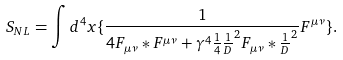<formula> <loc_0><loc_0><loc_500><loc_500>S _ { N L } = \int d ^ { 4 } x \{ \frac { 1 } { 4 { F } _ { \mu \nu } \ast { F } ^ { \mu \nu } + \gamma ^ { 4 } \frac { 1 } { 4 } \frac { 1 } { D } ^ { 2 } { F } _ { \mu \nu } \ast \frac { 1 } { D } ^ { 2 } } { F } ^ { \mu \nu } \} .</formula> 